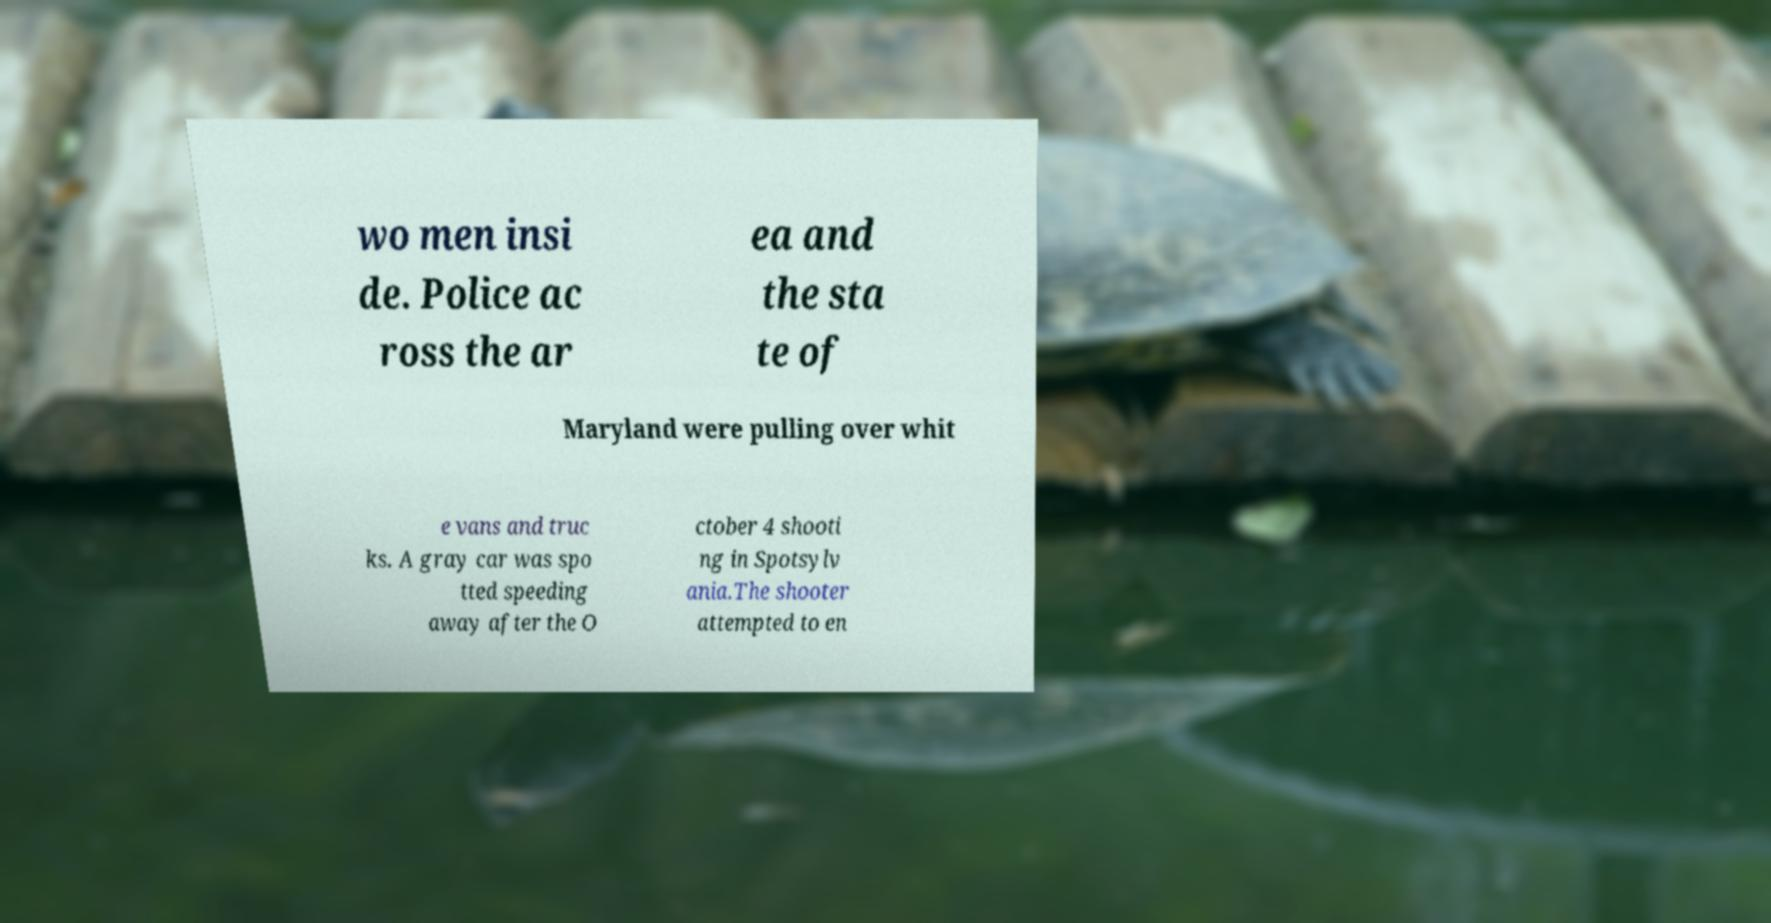Please read and relay the text visible in this image. What does it say? wo men insi de. Police ac ross the ar ea and the sta te of Maryland were pulling over whit e vans and truc ks. A gray car was spo tted speeding away after the O ctober 4 shooti ng in Spotsylv ania.The shooter attempted to en 